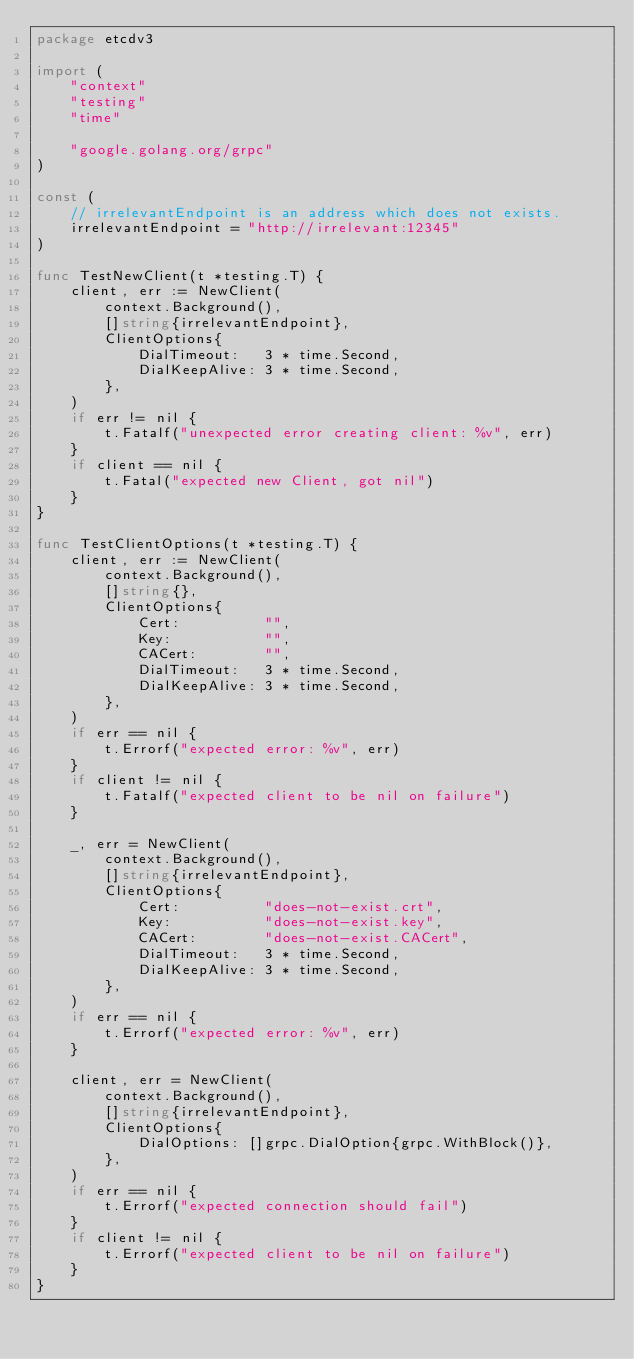Convert code to text. <code><loc_0><loc_0><loc_500><loc_500><_Go_>package etcdv3

import (
	"context"
	"testing"
	"time"

	"google.golang.org/grpc"
)

const (
	// irrelevantEndpoint is an address which does not exists.
	irrelevantEndpoint = "http://irrelevant:12345"
)

func TestNewClient(t *testing.T) {
	client, err := NewClient(
		context.Background(),
		[]string{irrelevantEndpoint},
		ClientOptions{
			DialTimeout:   3 * time.Second,
			DialKeepAlive: 3 * time.Second,
		},
	)
	if err != nil {
		t.Fatalf("unexpected error creating client: %v", err)
	}
	if client == nil {
		t.Fatal("expected new Client, got nil")
	}
}

func TestClientOptions(t *testing.T) {
	client, err := NewClient(
		context.Background(),
		[]string{},
		ClientOptions{
			Cert:          "",
			Key:           "",
			CACert:        "",
			DialTimeout:   3 * time.Second,
			DialKeepAlive: 3 * time.Second,
		},
	)
	if err == nil {
		t.Errorf("expected error: %v", err)
	}
	if client != nil {
		t.Fatalf("expected client to be nil on failure")
	}

	_, err = NewClient(
		context.Background(),
		[]string{irrelevantEndpoint},
		ClientOptions{
			Cert:          "does-not-exist.crt",
			Key:           "does-not-exist.key",
			CACert:        "does-not-exist.CACert",
			DialTimeout:   3 * time.Second,
			DialKeepAlive: 3 * time.Second,
		},
	)
	if err == nil {
		t.Errorf("expected error: %v", err)
	}

	client, err = NewClient(
		context.Background(),
		[]string{irrelevantEndpoint},
		ClientOptions{
			DialOptions: []grpc.DialOption{grpc.WithBlock()},
		},
	)
	if err == nil {
		t.Errorf("expected connection should fail")
	}
	if client != nil {
		t.Errorf("expected client to be nil on failure")
	}
}
</code> 